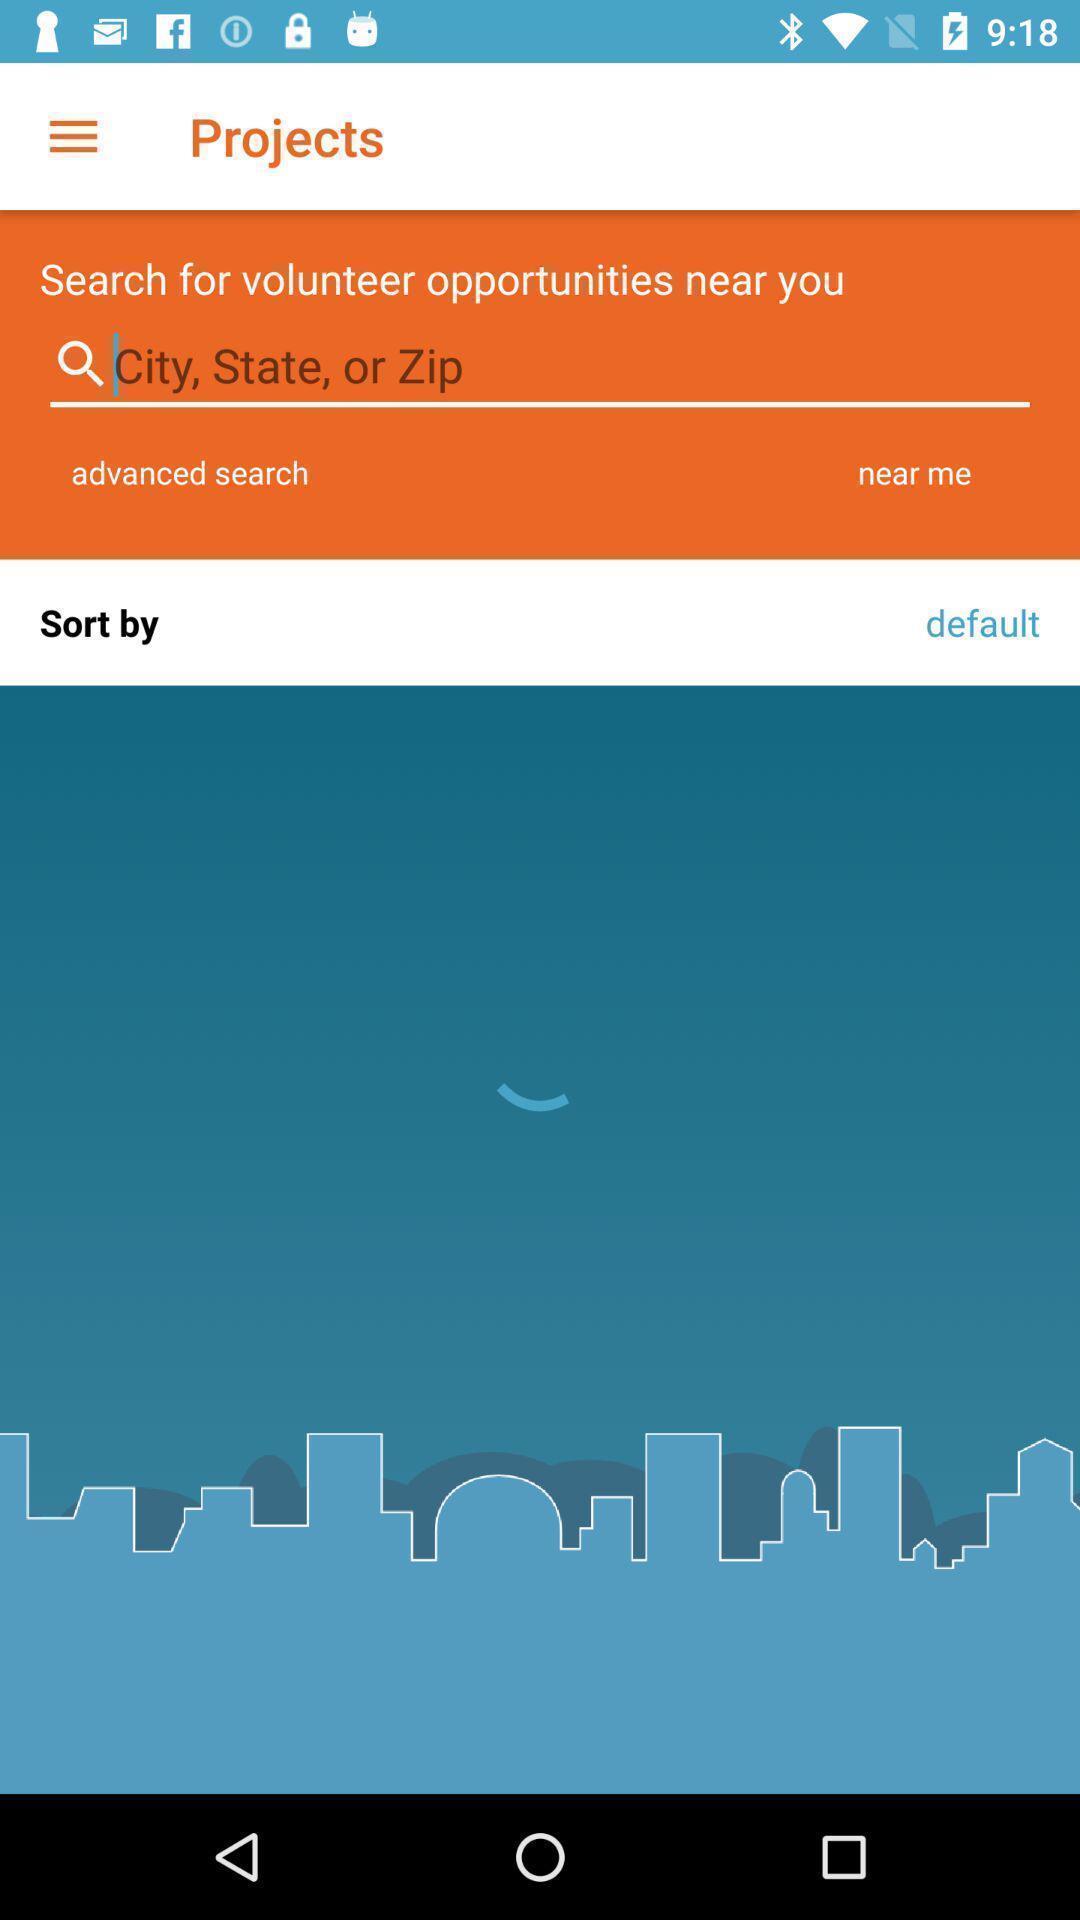Provide a detailed account of this screenshot. Search page. 